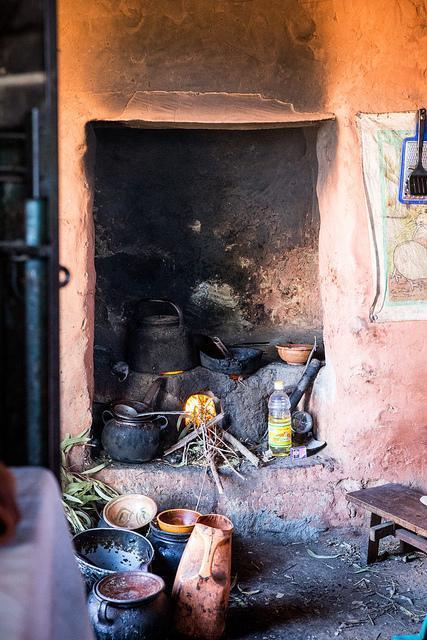How many bottles are in the picture?
Give a very brief answer. 1. 